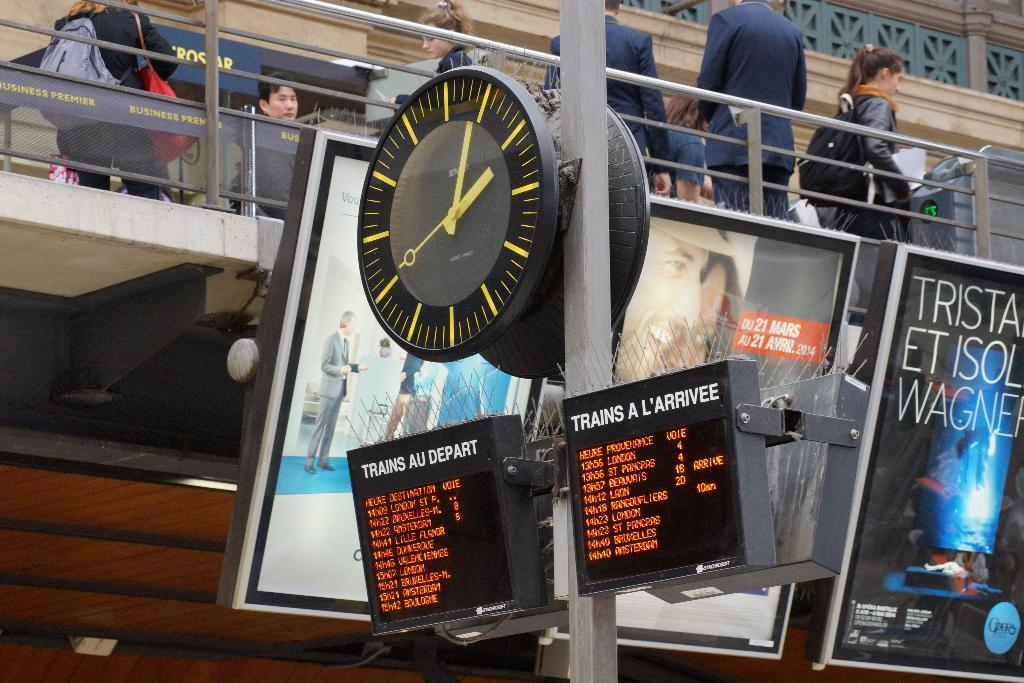<image>
Present a compact description of the photo's key features. Two displays are beneath a clock on a pole and one of them has the word depart on it. 